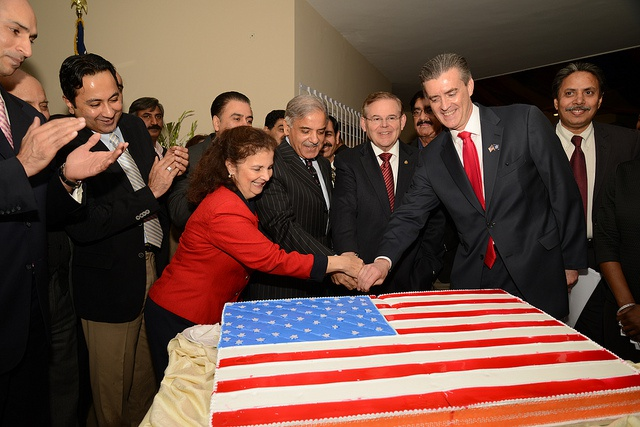Describe the objects in this image and their specific colors. I can see cake in tan, ivory, red, and gray tones, people in tan, black, salmon, and brown tones, people in tan, black, and salmon tones, people in tan, black, maroon, and salmon tones, and people in tan, brown, black, red, and maroon tones in this image. 